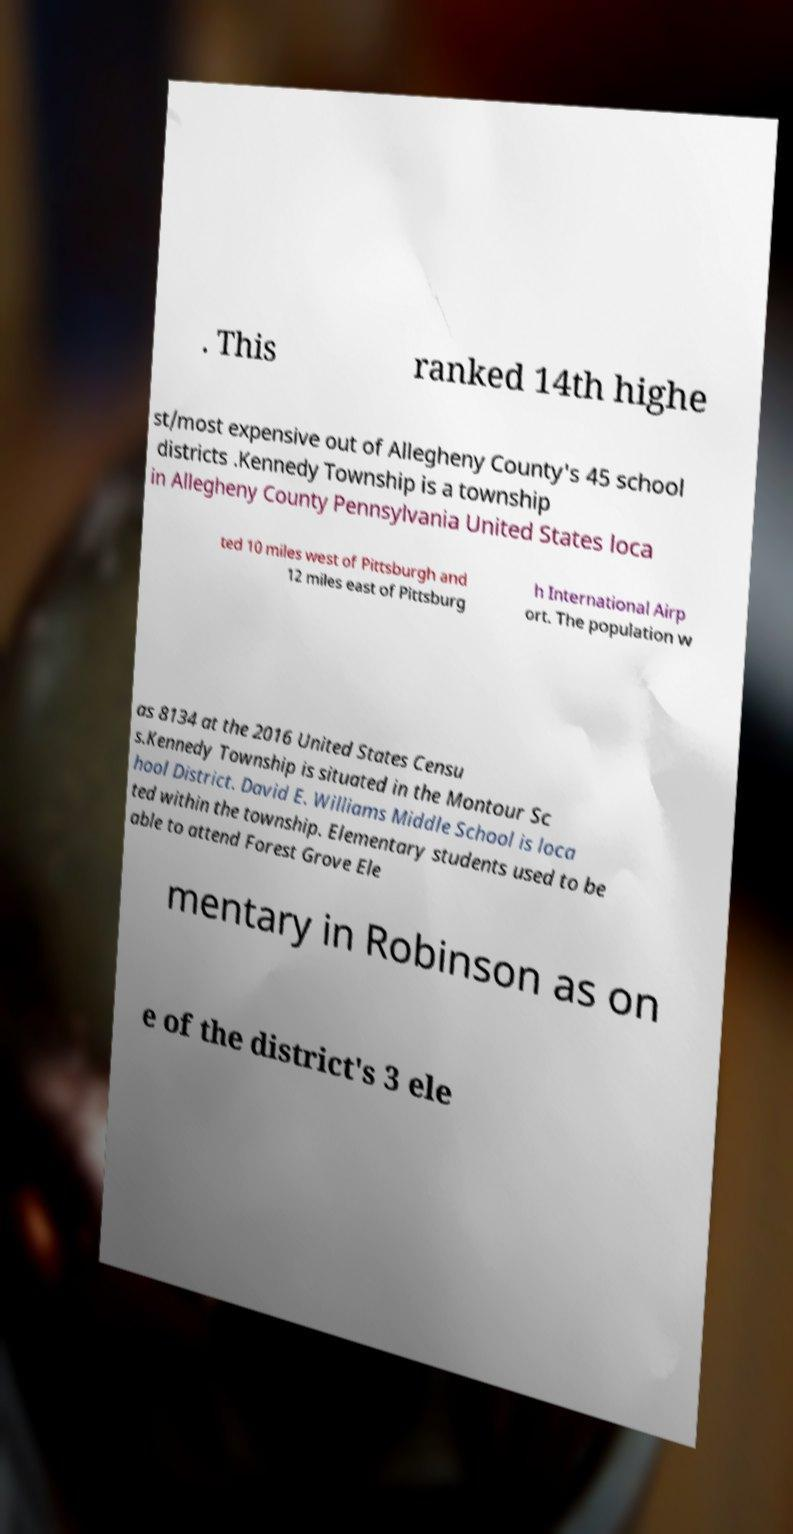There's text embedded in this image that I need extracted. Can you transcribe it verbatim? . This ranked 14th highe st/most expensive out of Allegheny County's 45 school districts .Kennedy Township is a township in Allegheny County Pennsylvania United States loca ted 10 miles west of Pittsburgh and 12 miles east of Pittsburg h International Airp ort. The population w as 8134 at the 2016 United States Censu s.Kennedy Township is situated in the Montour Sc hool District. David E. Williams Middle School is loca ted within the township. Elementary students used to be able to attend Forest Grove Ele mentary in Robinson as on e of the district's 3 ele 